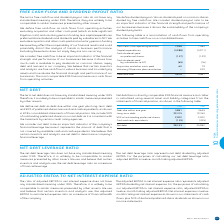According to Bce's financial document, How is free cash flow defined? cash flows from operating activities, excluding acquisition and other costs paid (which include significant litigation costs) and voluntary pension funding, less capital expenditures, preferred share dividends and dividends paid by subsidiaries to NCI. The document states: "We define free cash flow as cash flows from operating activities, excluding acquisition and other costs paid (which include significant litigation cos..." Also, Why is free cash flow considered an important indicator of the financial strength and performance of BCE's businesses? because it shows how much cash is available to pay dividends on common shares, repay debt and reinvest in our company. The document states: "ancial strength and performance of our businesses because it shows how much cash is available to pay dividends on common shares, repay debt and reinve..." Also, What is  Cash flows from operating activities for 2018? According to the financial document, 7,384. The relevant text states: "Cash flows from operating activities 7,958 7,384..." Also, can you calculate: What is the change in cash flows from operating activities? Based on the calculation: 7,958-7,384, the result is 574. This is based on the information: "Cash flows from operating activities 7,958 7,384 Cash flows from operating activities 7,958 7,384..." The key data points involved are: 7,384, 7,958. Also, can you calculate: What is the percentage change in free cash flow in 2019? To answer this question, I need to perform calculations using the financial data. The calculation is: (3,818-3,567)/3,567, which equals 7.04 (percentage). This is based on the information: "Free cash flow 3,818 3,567 Free cash flow 3,818 3,567..." The key data points involved are: 3,567, 3,818. Also, can you calculate: What is the total amount of acquisition and other costs paid in 2018 and 2019? Based on the calculation: 60+79, the result is 139. This is based on the information: "Acquisition and other costs paid 60 79 Acquisition and other costs paid 60 79..." The key data points involved are: 60, 79. 